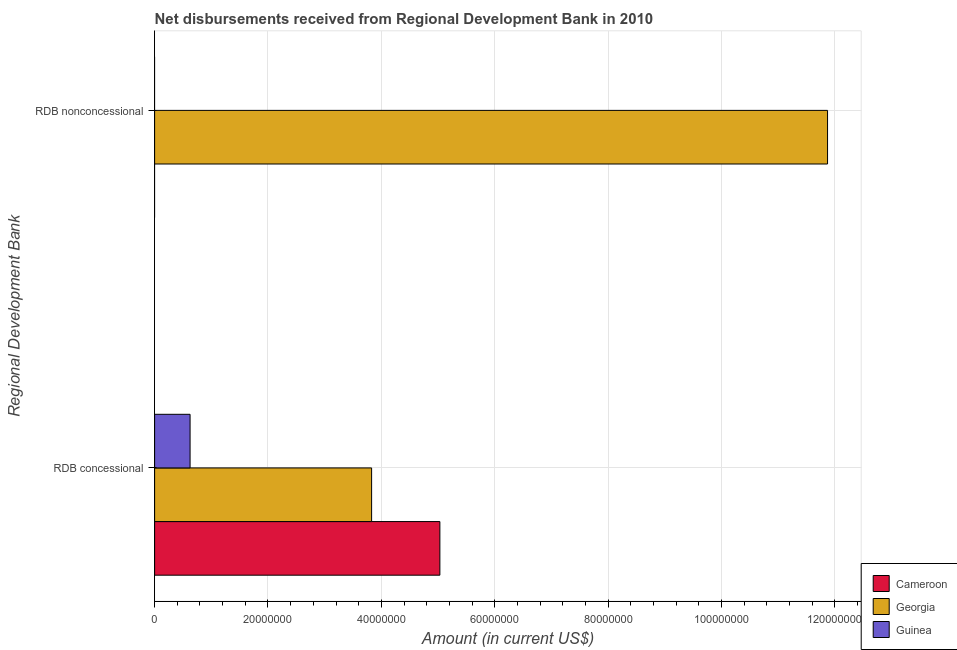How many different coloured bars are there?
Your response must be concise. 3. Are the number of bars per tick equal to the number of legend labels?
Your answer should be very brief. No. Are the number of bars on each tick of the Y-axis equal?
Ensure brevity in your answer.  No. How many bars are there on the 2nd tick from the top?
Provide a succinct answer. 3. How many bars are there on the 1st tick from the bottom?
Provide a short and direct response. 3. What is the label of the 1st group of bars from the top?
Give a very brief answer. RDB nonconcessional. What is the net concessional disbursements from rdb in Cameroon?
Your response must be concise. 5.03e+07. Across all countries, what is the maximum net concessional disbursements from rdb?
Keep it short and to the point. 5.03e+07. Across all countries, what is the minimum net non concessional disbursements from rdb?
Ensure brevity in your answer.  0. In which country was the net non concessional disbursements from rdb maximum?
Make the answer very short. Georgia. What is the total net concessional disbursements from rdb in the graph?
Your answer should be very brief. 9.49e+07. What is the difference between the net concessional disbursements from rdb in Georgia and that in Guinea?
Provide a short and direct response. 3.20e+07. What is the difference between the net concessional disbursements from rdb in Georgia and the net non concessional disbursements from rdb in Guinea?
Your answer should be very brief. 3.83e+07. What is the average net concessional disbursements from rdb per country?
Your answer should be very brief. 3.16e+07. What is the difference between the net concessional disbursements from rdb and net non concessional disbursements from rdb in Georgia?
Ensure brevity in your answer.  -8.04e+07. In how many countries, is the net non concessional disbursements from rdb greater than 108000000 US$?
Your answer should be very brief. 1. What is the ratio of the net concessional disbursements from rdb in Guinea to that in Cameroon?
Provide a succinct answer. 0.12. What is the difference between two consecutive major ticks on the X-axis?
Offer a very short reply. 2.00e+07. Does the graph contain grids?
Provide a short and direct response. Yes. How many legend labels are there?
Offer a terse response. 3. How are the legend labels stacked?
Offer a very short reply. Vertical. What is the title of the graph?
Provide a short and direct response. Net disbursements received from Regional Development Bank in 2010. Does "Isle of Man" appear as one of the legend labels in the graph?
Your answer should be very brief. No. What is the label or title of the X-axis?
Ensure brevity in your answer.  Amount (in current US$). What is the label or title of the Y-axis?
Give a very brief answer. Regional Development Bank. What is the Amount (in current US$) in Cameroon in RDB concessional?
Make the answer very short. 5.03e+07. What is the Amount (in current US$) of Georgia in RDB concessional?
Your response must be concise. 3.83e+07. What is the Amount (in current US$) in Guinea in RDB concessional?
Give a very brief answer. 6.26e+06. What is the Amount (in current US$) of Georgia in RDB nonconcessional?
Offer a terse response. 1.19e+08. Across all Regional Development Bank, what is the maximum Amount (in current US$) in Cameroon?
Provide a succinct answer. 5.03e+07. Across all Regional Development Bank, what is the maximum Amount (in current US$) of Georgia?
Ensure brevity in your answer.  1.19e+08. Across all Regional Development Bank, what is the maximum Amount (in current US$) of Guinea?
Your response must be concise. 6.26e+06. Across all Regional Development Bank, what is the minimum Amount (in current US$) of Cameroon?
Your response must be concise. 0. Across all Regional Development Bank, what is the minimum Amount (in current US$) in Georgia?
Give a very brief answer. 3.83e+07. What is the total Amount (in current US$) of Cameroon in the graph?
Provide a succinct answer. 5.03e+07. What is the total Amount (in current US$) in Georgia in the graph?
Your answer should be compact. 1.57e+08. What is the total Amount (in current US$) in Guinea in the graph?
Keep it short and to the point. 6.26e+06. What is the difference between the Amount (in current US$) in Georgia in RDB concessional and that in RDB nonconcessional?
Make the answer very short. -8.04e+07. What is the difference between the Amount (in current US$) in Cameroon in RDB concessional and the Amount (in current US$) in Georgia in RDB nonconcessional?
Offer a terse response. -6.84e+07. What is the average Amount (in current US$) of Cameroon per Regional Development Bank?
Make the answer very short. 2.52e+07. What is the average Amount (in current US$) of Georgia per Regional Development Bank?
Make the answer very short. 7.85e+07. What is the average Amount (in current US$) in Guinea per Regional Development Bank?
Your response must be concise. 3.13e+06. What is the difference between the Amount (in current US$) in Cameroon and Amount (in current US$) in Georgia in RDB concessional?
Keep it short and to the point. 1.20e+07. What is the difference between the Amount (in current US$) of Cameroon and Amount (in current US$) of Guinea in RDB concessional?
Provide a short and direct response. 4.41e+07. What is the difference between the Amount (in current US$) in Georgia and Amount (in current US$) in Guinea in RDB concessional?
Make the answer very short. 3.20e+07. What is the ratio of the Amount (in current US$) of Georgia in RDB concessional to that in RDB nonconcessional?
Your answer should be very brief. 0.32. What is the difference between the highest and the second highest Amount (in current US$) of Georgia?
Provide a succinct answer. 8.04e+07. What is the difference between the highest and the lowest Amount (in current US$) in Cameroon?
Provide a succinct answer. 5.03e+07. What is the difference between the highest and the lowest Amount (in current US$) of Georgia?
Provide a short and direct response. 8.04e+07. What is the difference between the highest and the lowest Amount (in current US$) in Guinea?
Ensure brevity in your answer.  6.26e+06. 